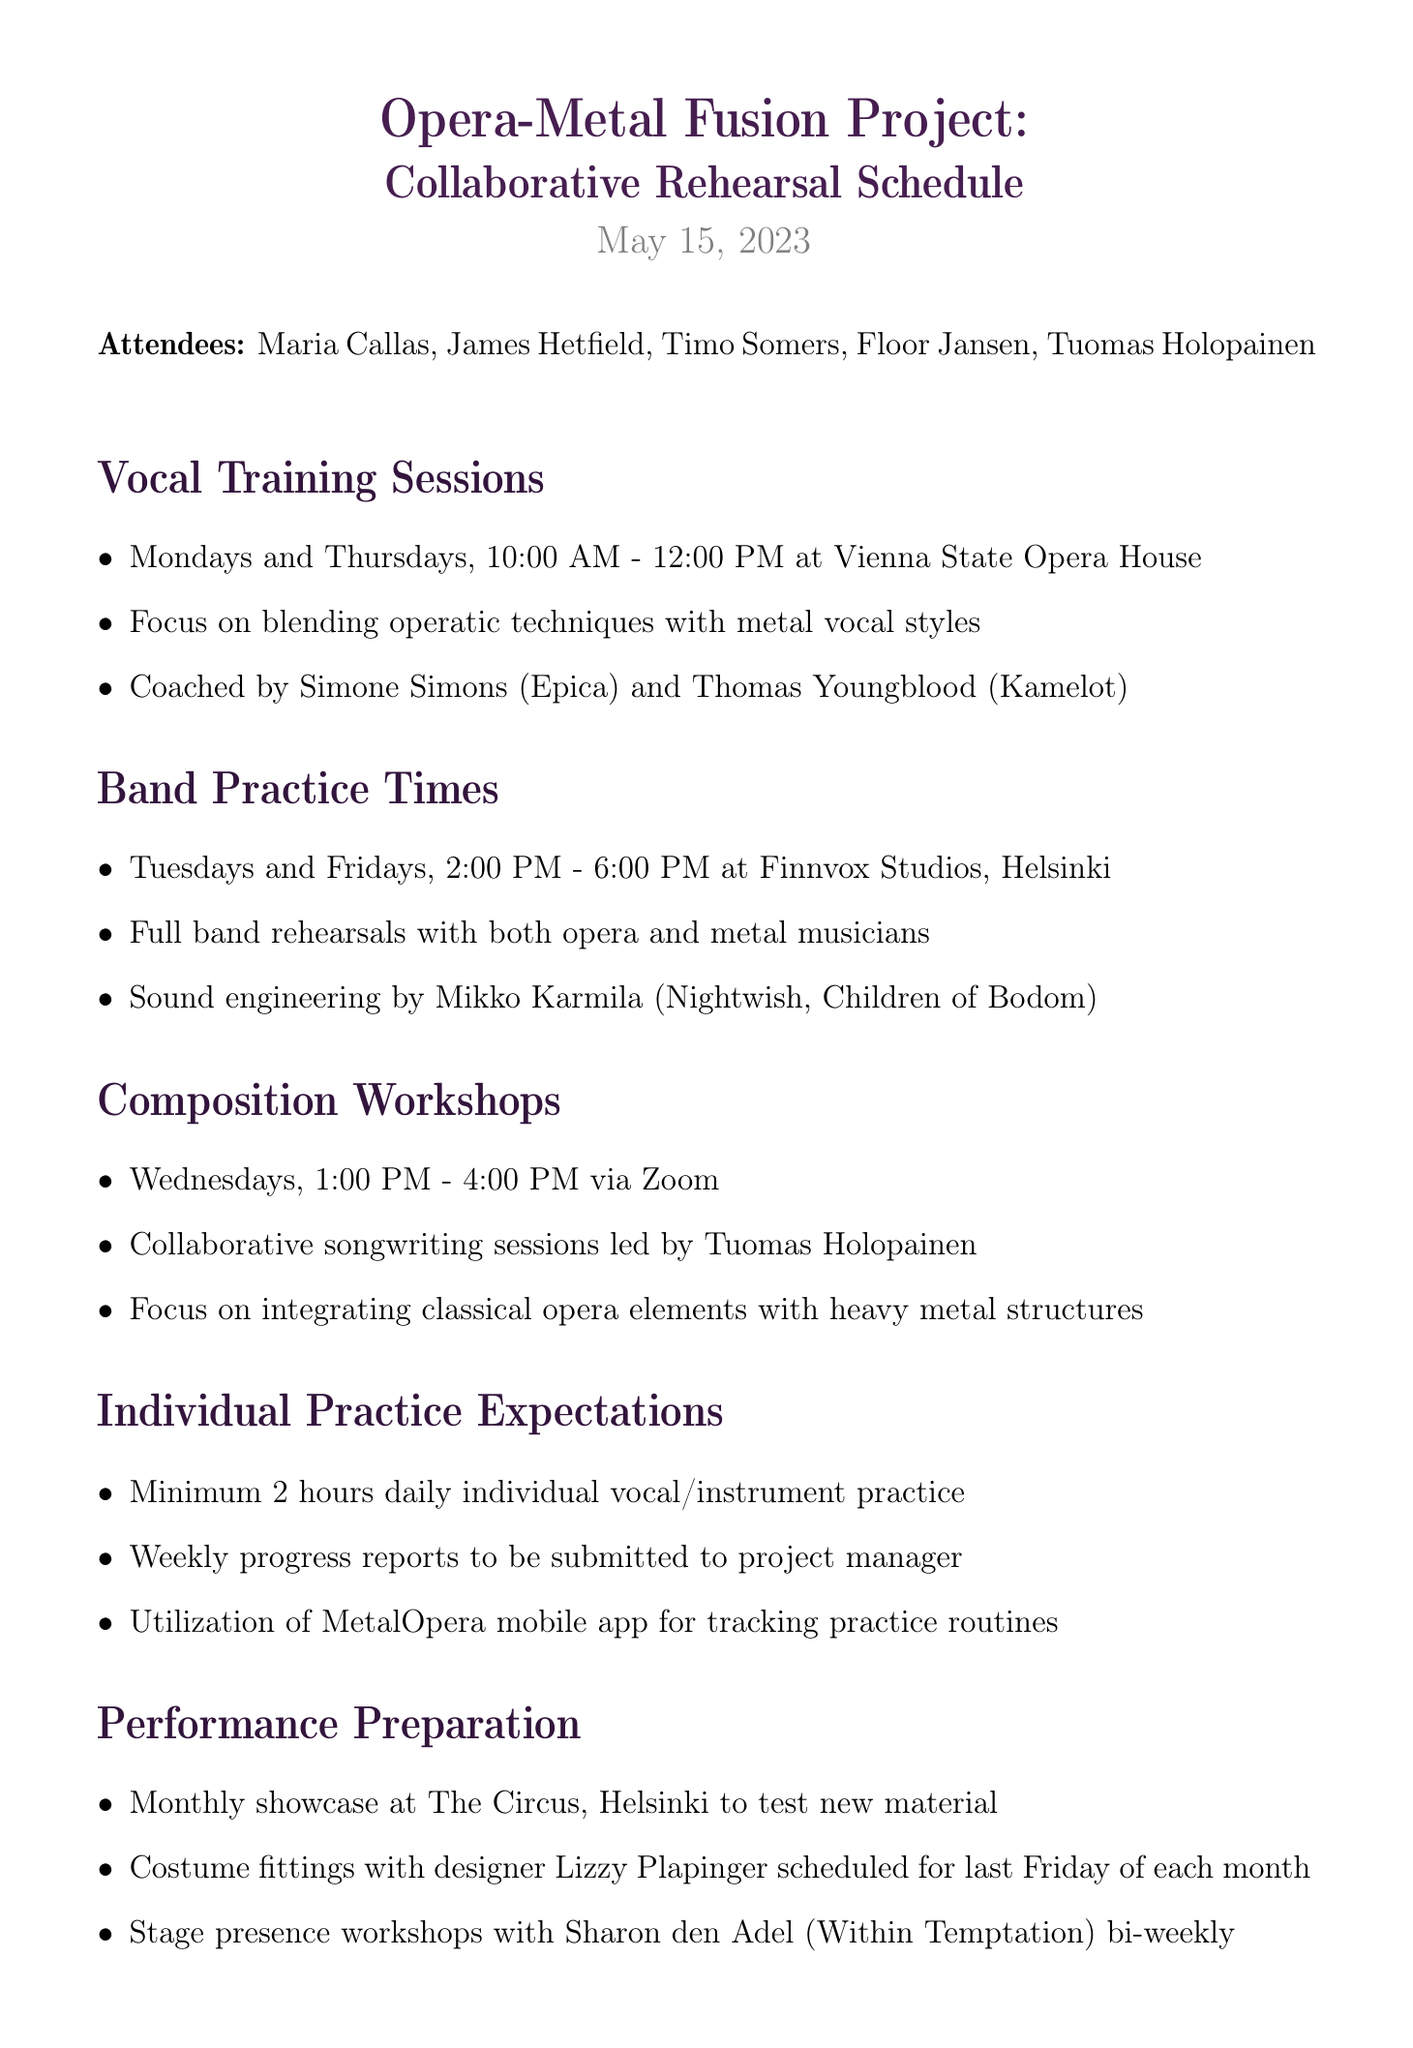What are the vocal training session days? The vocal training sessions are scheduled for Mondays and Thursdays.
Answer: Mondays and Thursdays What is the time for band practice? The band practice times are from 2:00 PM to 6:00 PM.
Answer: 2:00 PM - 6:00 PM Who is coaching the vocal training sessions? The document states that Simone Simons and Thomas Youngblood are coaching the sessions.
Answer: Simone Simons and Thomas Youngblood Where are the individual practice sessions expected to take place? Individual practice can happen anywhere, but a mobile app is mentioned for tracking, implying practice is done individually.
Answer: N/A What is the frequency of the performance showcases? The document indicates that these showcases occur monthly.
Answer: Monthly Who leads the composition workshops? Tuomas Holopainen is mentioned as the leader of the composition workshops.
Answer: Tuomas Holopainen What city hosts the band practice? The band practice sessions are held in Helsinki.
Answer: Helsinki How long is each vocal training session? The training sessions are two hours long, from 10:00 AM to 12:00 PM.
Answer: Two hours 